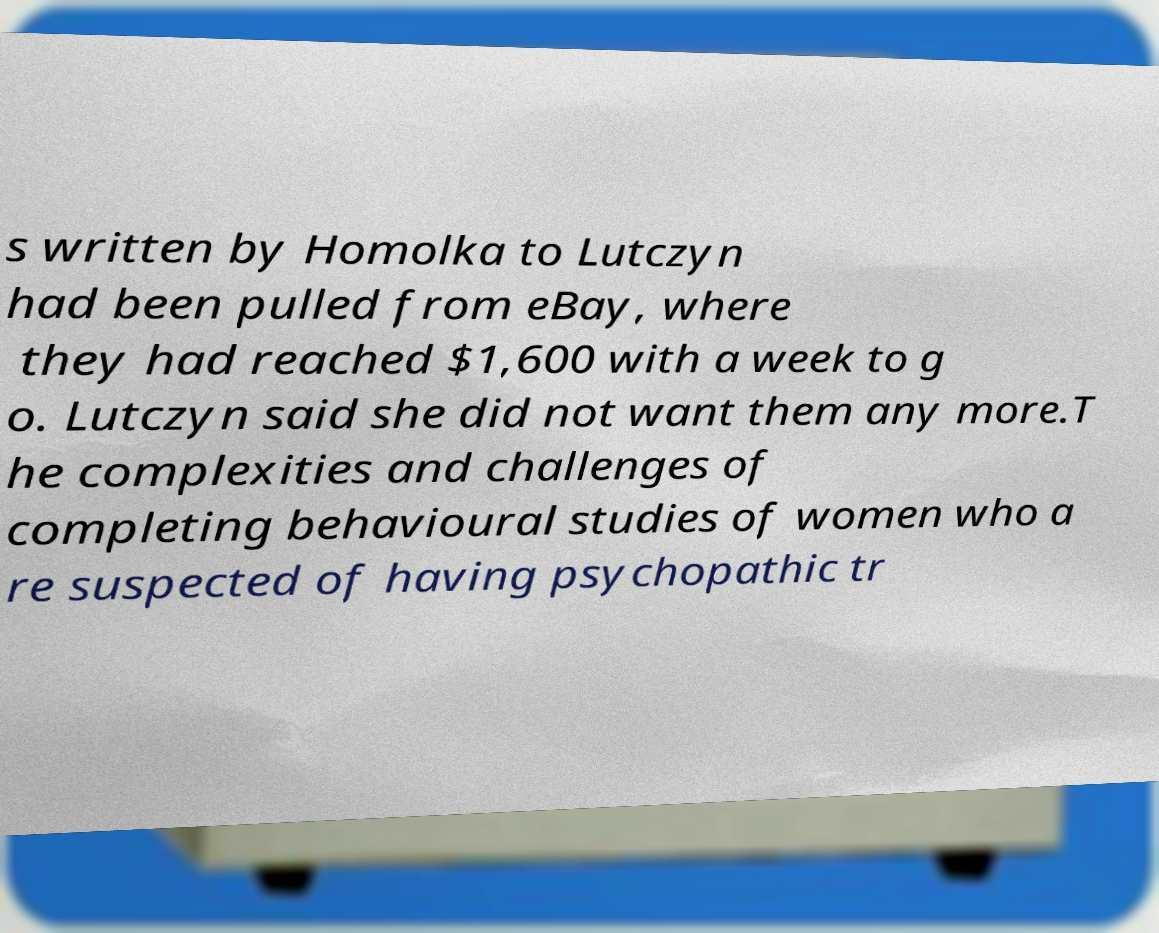Could you extract and type out the text from this image? s written by Homolka to Lutczyn had been pulled from eBay, where they had reached $1,600 with a week to g o. Lutczyn said she did not want them any more.T he complexities and challenges of completing behavioural studies of women who a re suspected of having psychopathic tr 